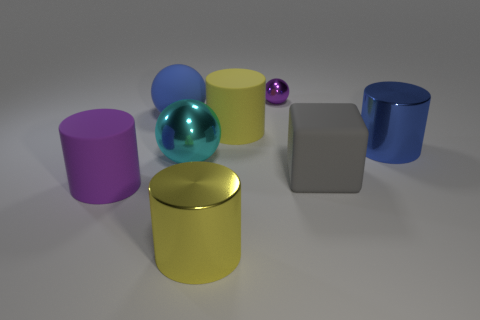Subtract 1 cylinders. How many cylinders are left? 3 Subtract all cubes. How many objects are left? 7 Add 1 purple balls. How many objects exist? 9 Add 6 large yellow things. How many large yellow things are left? 8 Add 1 large blue objects. How many large blue objects exist? 3 Subtract 0 red spheres. How many objects are left? 8 Subtract all large cyan metal things. Subtract all tiny brown rubber cylinders. How many objects are left? 7 